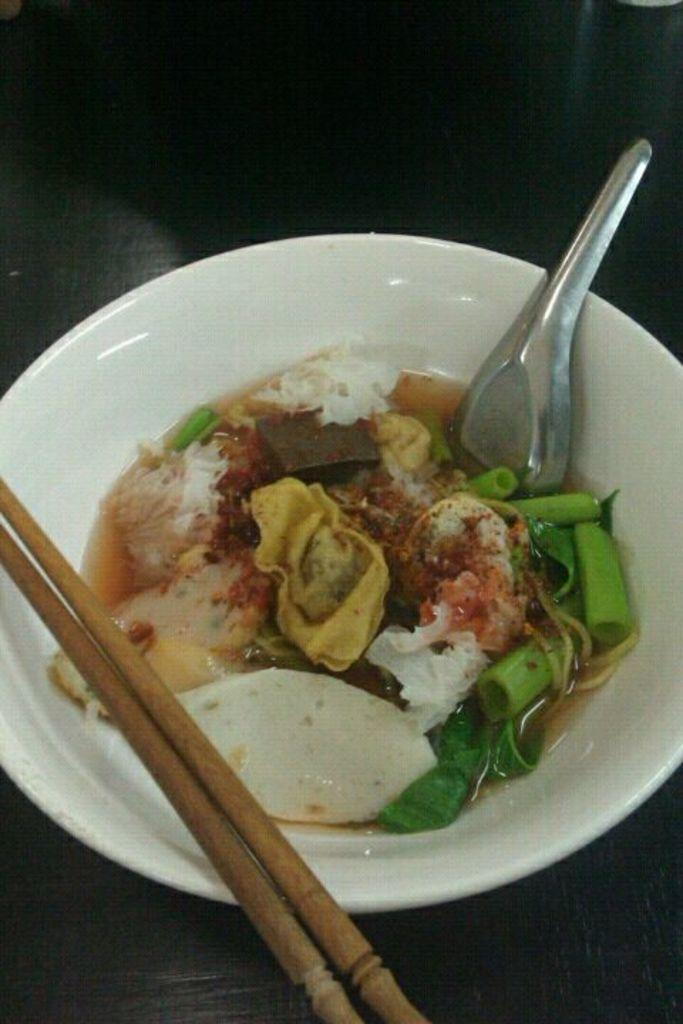What is in the bowl that is visible in the image? There is a bowl with food in the image. What utensil is placed in the bowl? There is a spoon in the bowl. What other utensil is present near the bowl? Chopsticks are present on the bowl. What color is the pear on the table in the image? There is no pear present in the image. 